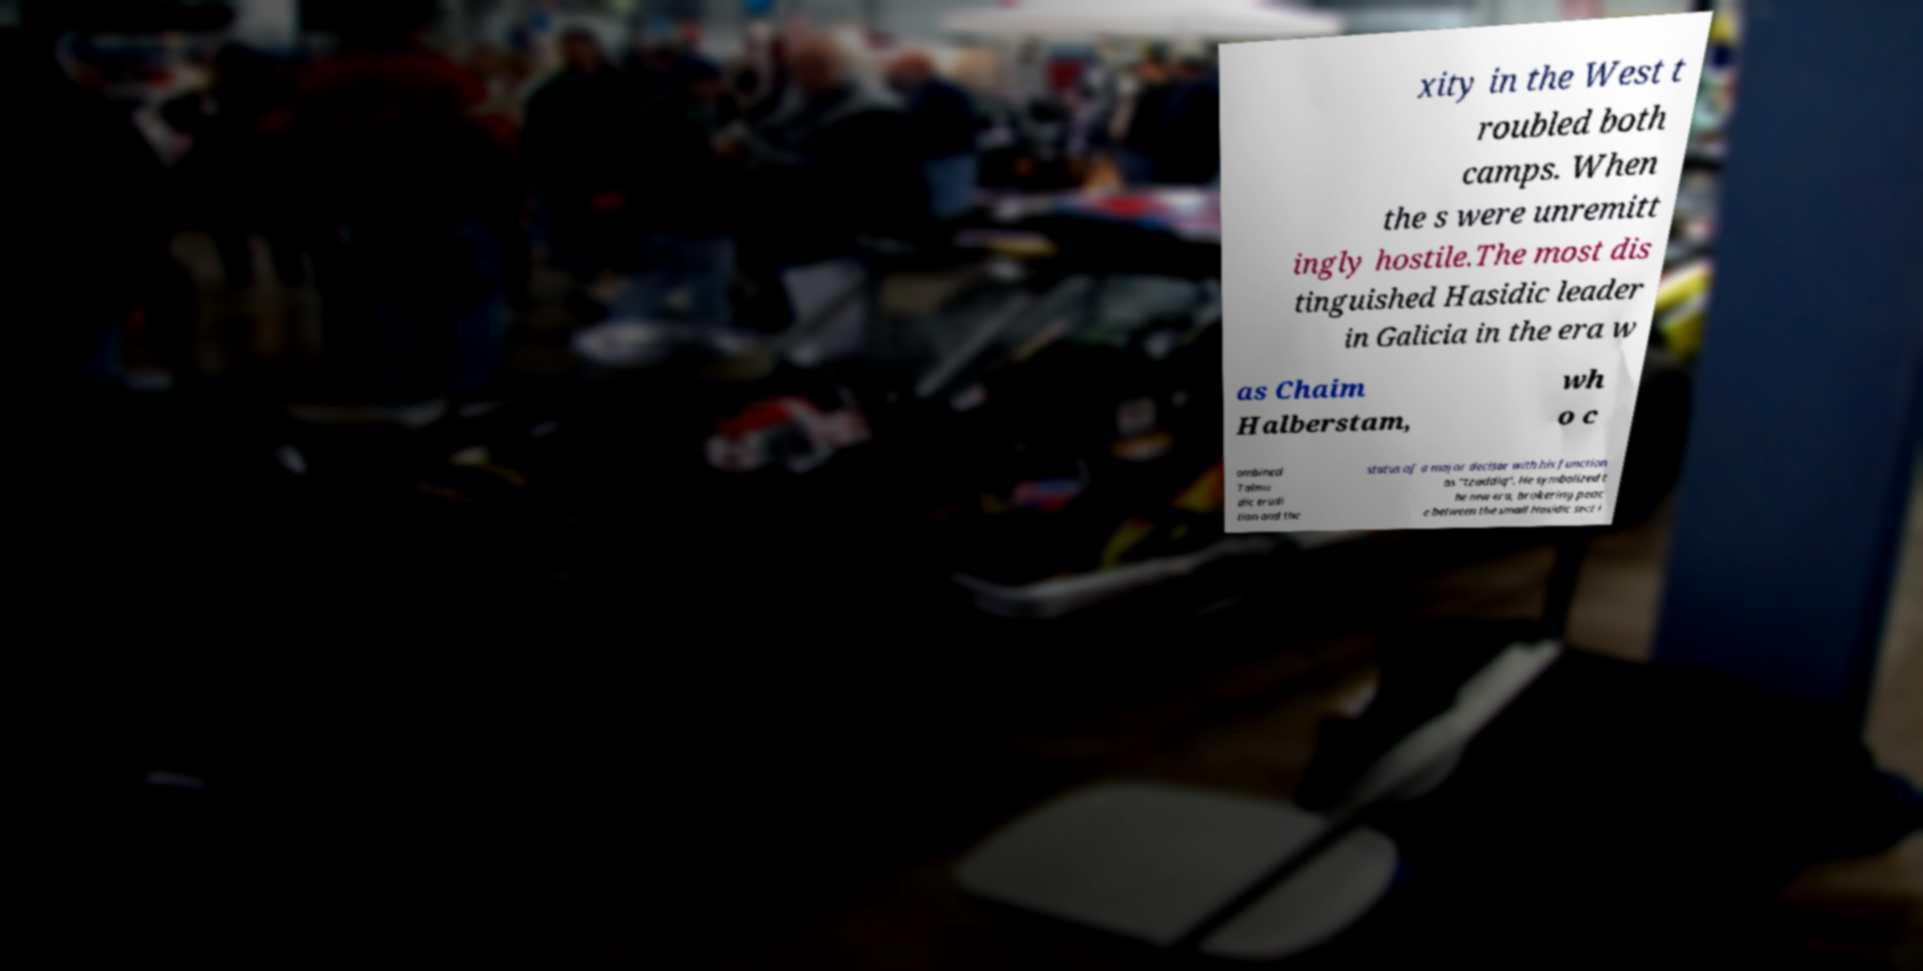I need the written content from this picture converted into text. Can you do that? xity in the West t roubled both camps. When the s were unremitt ingly hostile.The most dis tinguished Hasidic leader in Galicia in the era w as Chaim Halberstam, wh o c ombined Talmu dic erudi tion and the status of a major decisor with his function as "tzaddiq". He symbolized t he new era, brokering peac e between the small Hasidic sect i 